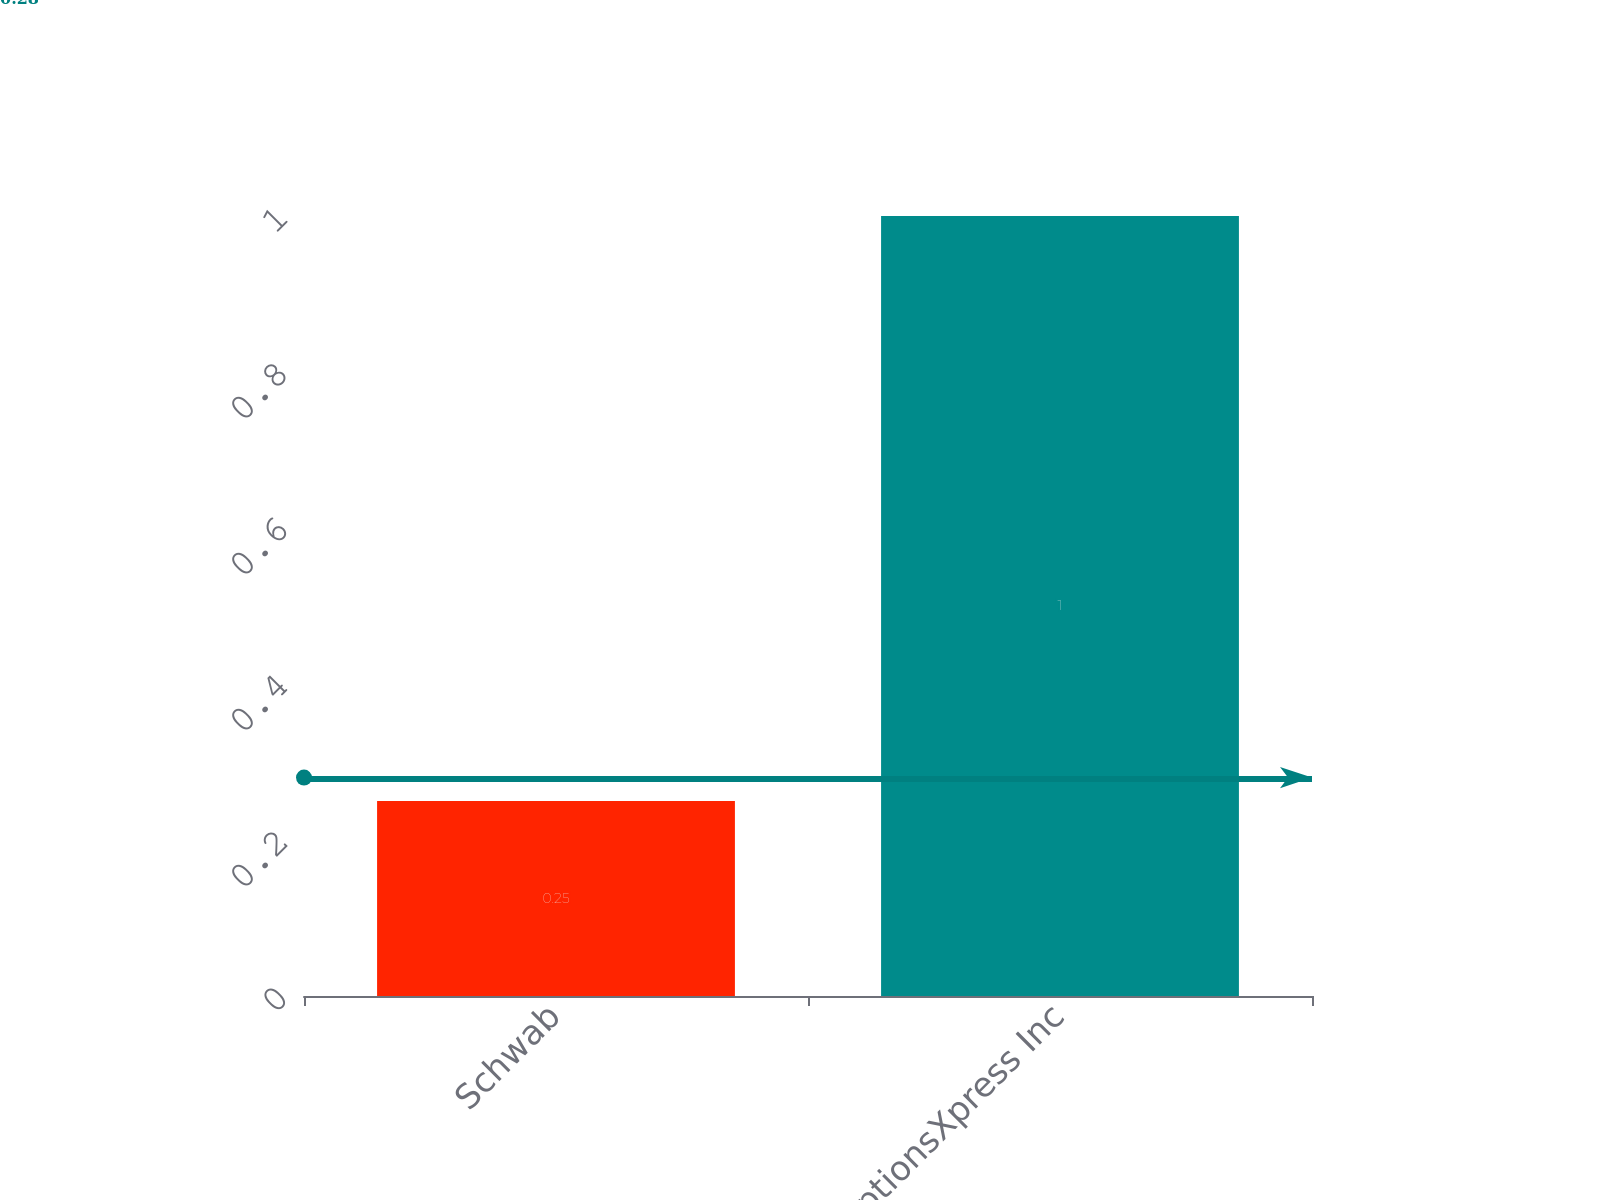Convert chart. <chart><loc_0><loc_0><loc_500><loc_500><bar_chart><fcel>Schwab<fcel>optionsXpress Inc<nl><fcel>0.25<fcel>1<nl></chart> 